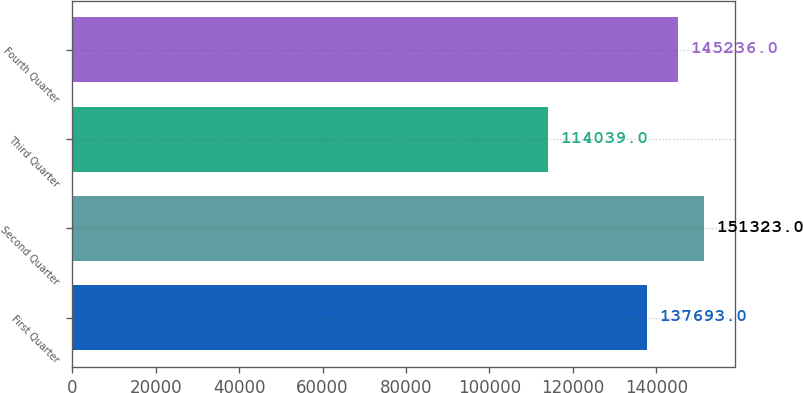Convert chart. <chart><loc_0><loc_0><loc_500><loc_500><bar_chart><fcel>First Quarter<fcel>Second Quarter<fcel>Third Quarter<fcel>Fourth Quarter<nl><fcel>137693<fcel>151323<fcel>114039<fcel>145236<nl></chart> 